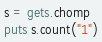<code> <loc_0><loc_0><loc_500><loc_500><_Ruby_>s = gets.chomp
puts s.count("1")</code> 